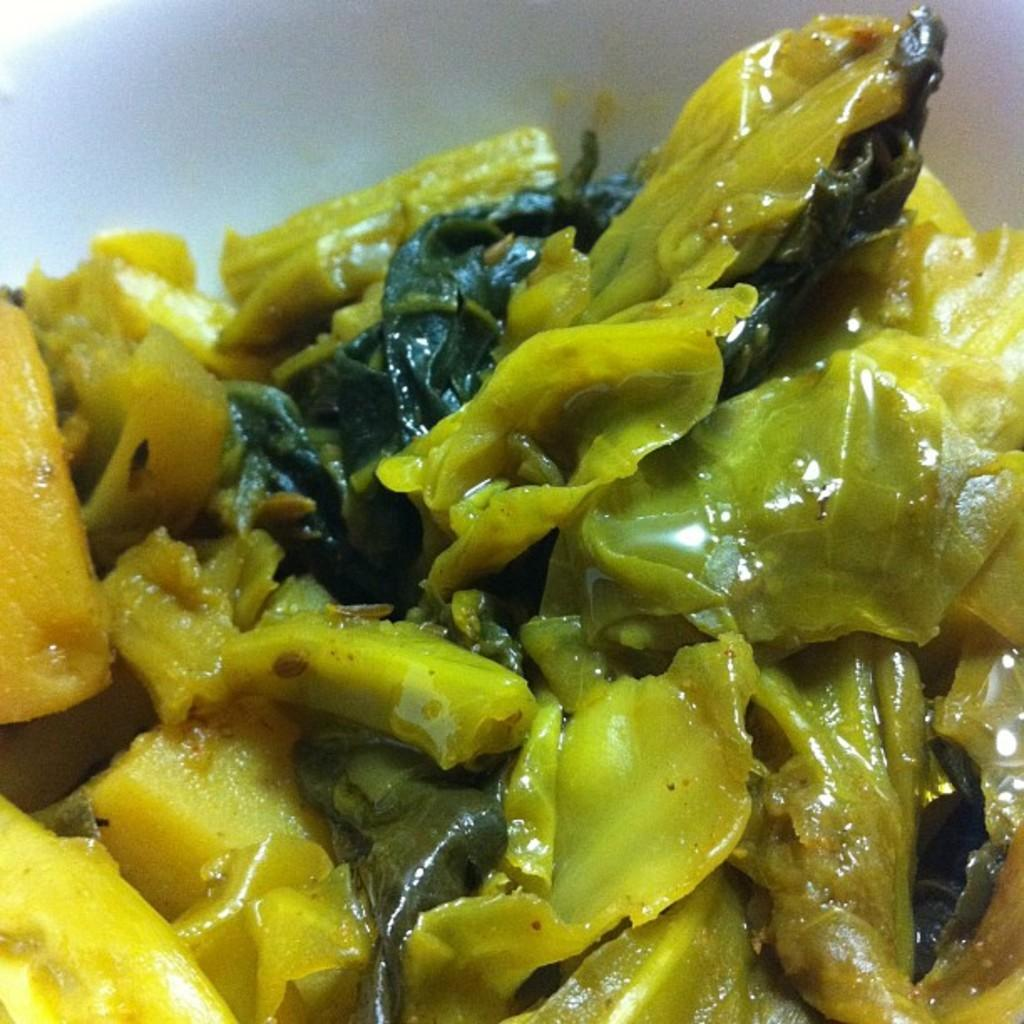What is in the bowl that is visible in the image? There is a bowl containing food in the image. What type of pear is used in the arithmetic problem on the roof in the image? There is no pear or arithmetic problem on a roof present in the image. 